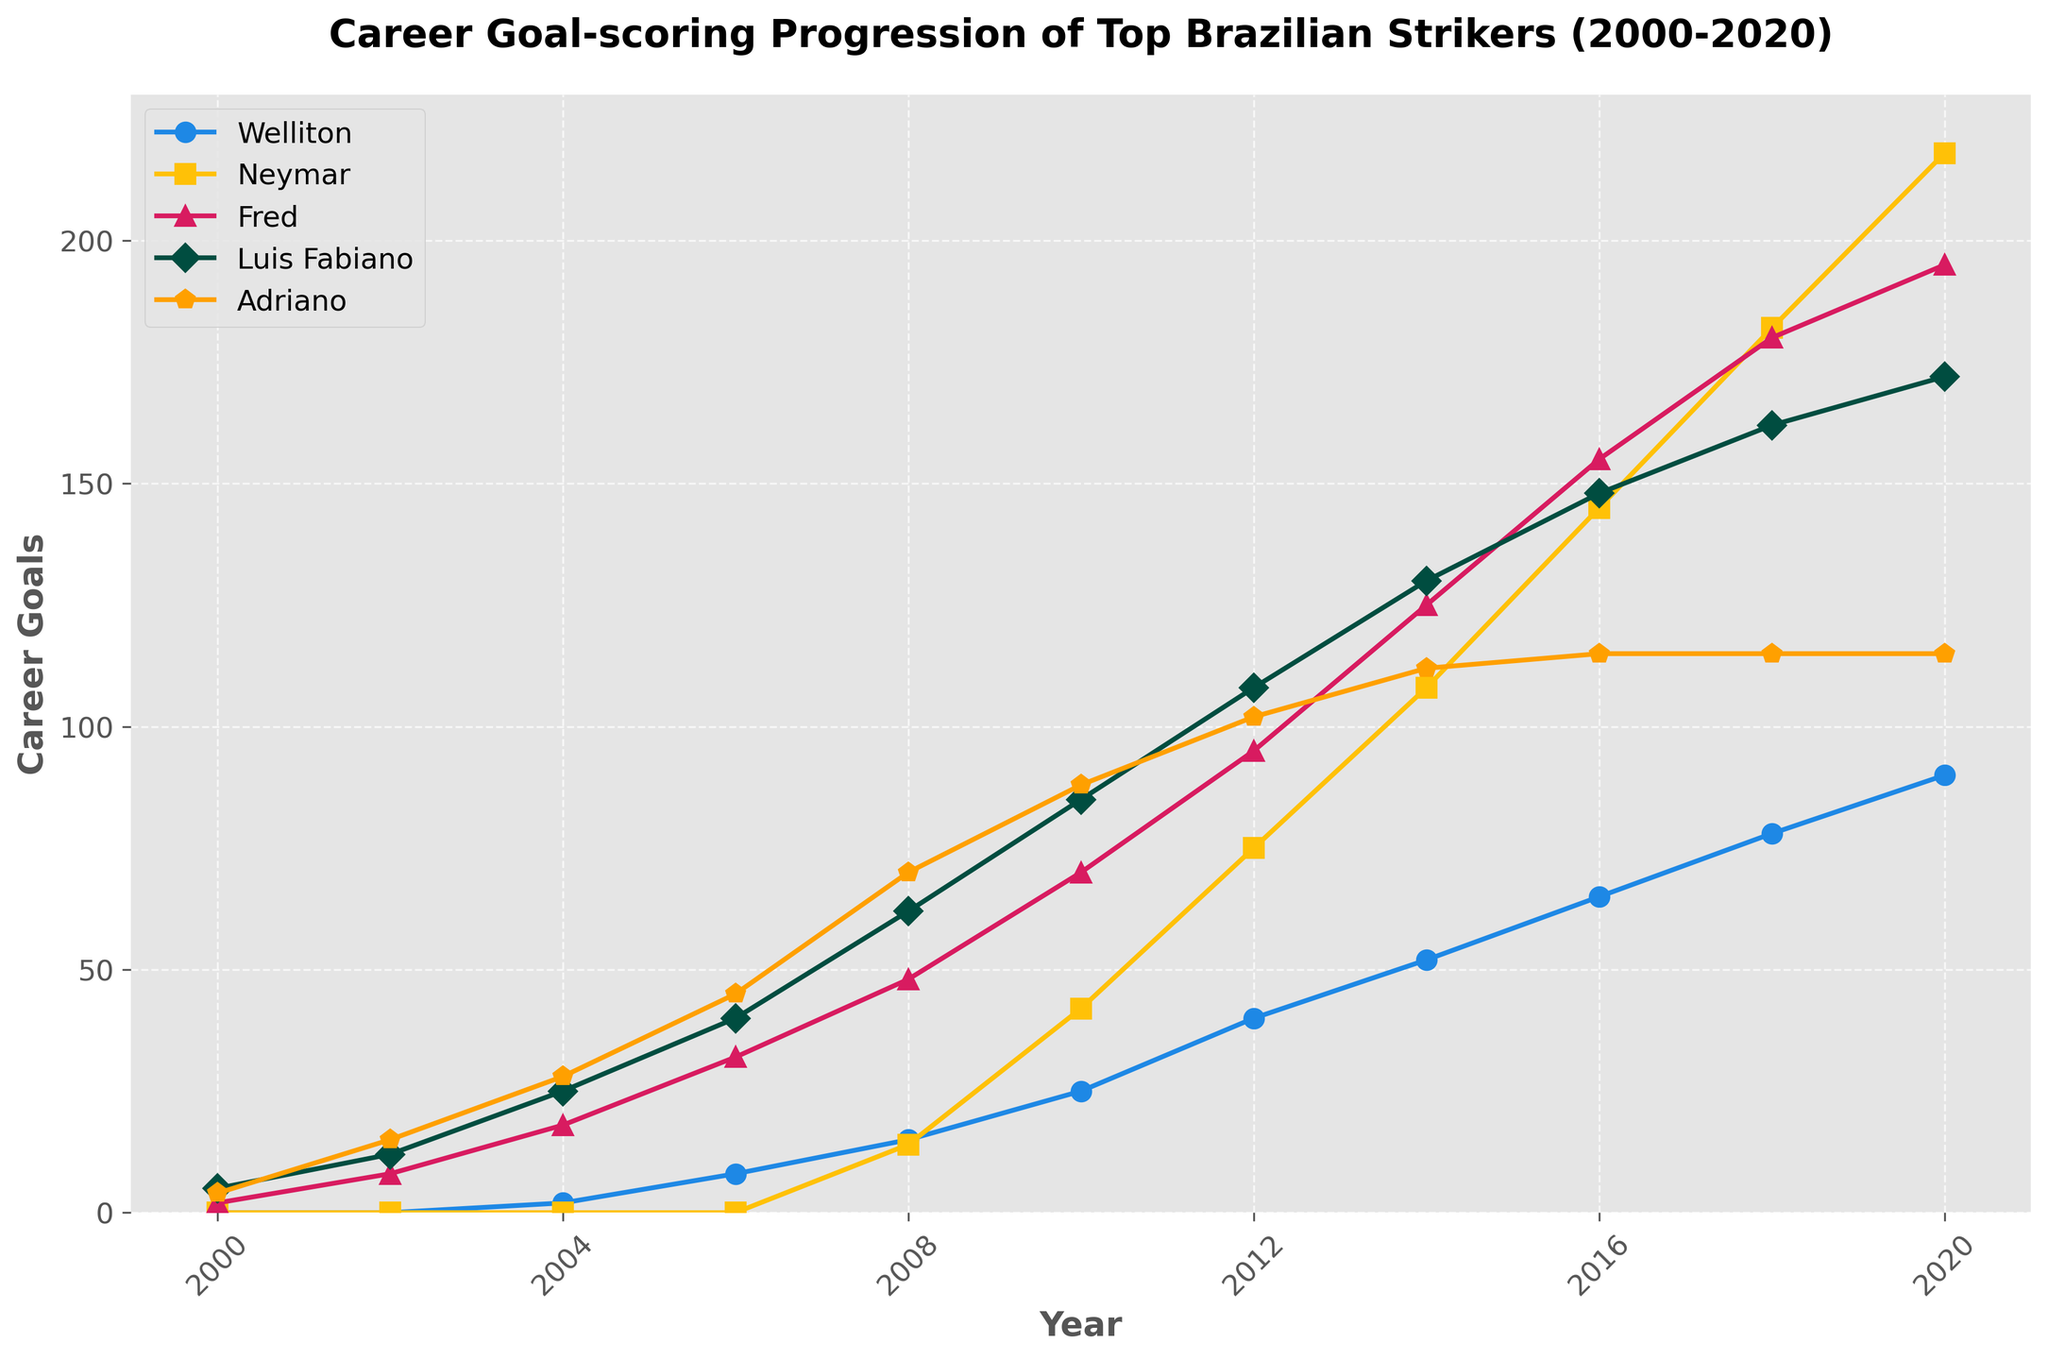How many more goals did Neymar score than Fred by 2020? Compare the number of goals scored by Neymar and Fred in the year 2020 from the line chart. Neymar scored 218 goals while Fred scored 195. Subtract Fred's goals from Neymar's goals: 218 - 195 = 23
Answer: 23 When did Fred surpass 100 career goals? Identify when Fred's line crosses the 100-goal mark. This occurs at the year 2012 where his career goals reach 95 and surpass 100 in 2014.
Answer: 2014 Which striker has consistently scored the same number of goals from 2016 to 2020? Examine the lines from 2016 to 2020 and identify any line that remains flat without increasing goals. Adriano's line is flat from 2016 to 2020 with 115 goals.
Answer: Adriano In which year did Neymar's career goals first exceed 100? Look at the line for Neymar and identify the first year it surpasses the 100-goal mark. This happens between 2010 and 2012. In 2012, Neymar's career goals stand at 108.
Answer: 2012 Compare the growth rate of Welliton’s and Neymar’s career goals between 2010 and 2020. Which player had a greater increase? Subtract the number of goals from 2010 and 2020 for both players. Welliton's increase: 90 - 25 = 65, Neymar's increase: 218 - 42 = 176. Neymar had a greater increase.
Answer: Neymar Who had scored more goals by 2008, Luis Fabiano or Adriano? Compare the career goals of Luis Fabiano and Adriano in the year 2008. Luis Fabiano had 62 goals while Adriano had 70 goals. Adriano scored more.
Answer: Adriano What is the average number of goals scored by Welliton from 2008 to 2012? Sum Welliton's goals from 2008, 2010, and 2012: 15 + 25 + 40 = 80. Divide by the number of data points: 80 / 3 ≈ 26.67
Answer: 26.67 Which player had the least number of career goals in 2006? Compare the goals of Welliton, Neymar, Fred, Luis Fabiano, and Adriano in 2006. Welliton had the least number of goals with 8.
Answer: Welliton How many total goals did Luis Fabiano score from 2000 to 2010? Sum Luis Fabiano's career goals from 2000, 2002, 2004, 2006, 2008 and 2010: 5 + 12 + 25 + 40 + 62 + 85 = 229
Answer: 229 By what percentage did Fred's career goals increase from 2010 to 2014? Calculate the initial and final values: Fred’s career goals in 2010 were 70 and in 2014 they were 125. Calculate the increase: 125 - 70 = 55. Divide by the initial value and multiply by 100: (55 / 70) × 100 ≈ 78.57%
Answer: 78.57% 